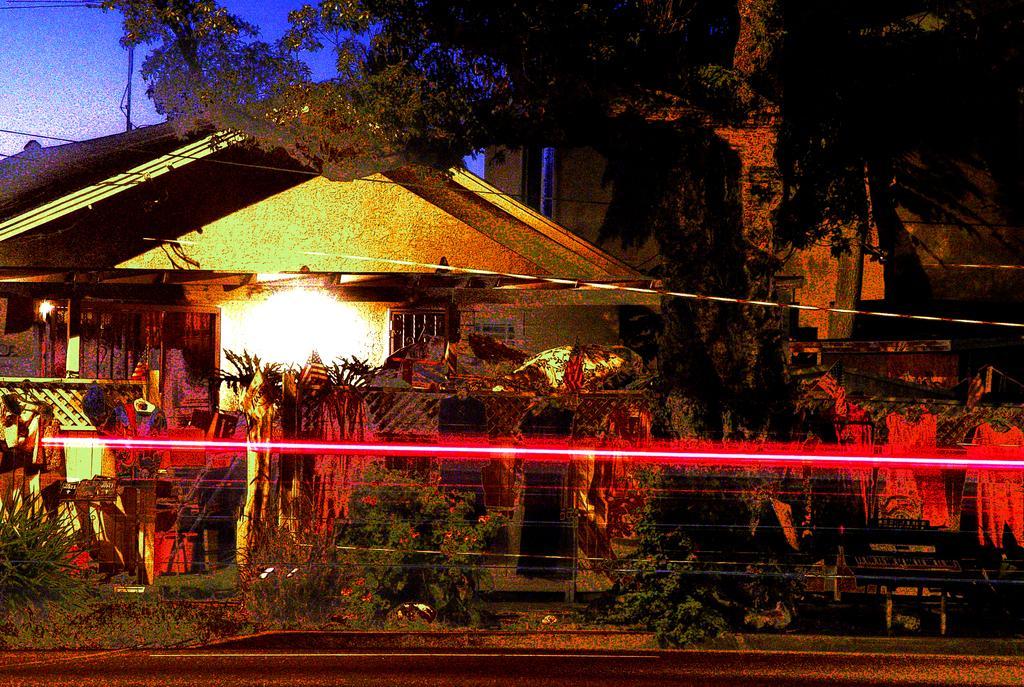Can you describe this image briefly? In this image there are houses, trees, plants, flower pots, wall, lights and some objects. At the bottom there is a road, and at the top there are some wires, pole and sky. 